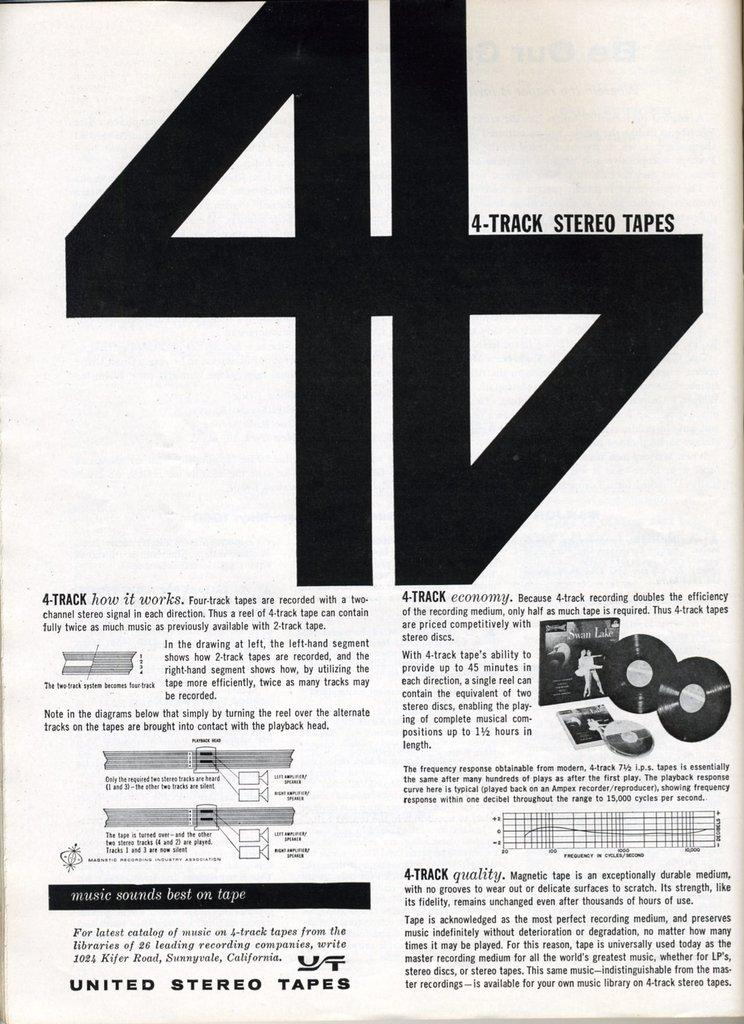<image>
Give a short and clear explanation of the subsequent image. An instruction sheet for 4-track stereo tapes by United Stereo Tapes. 